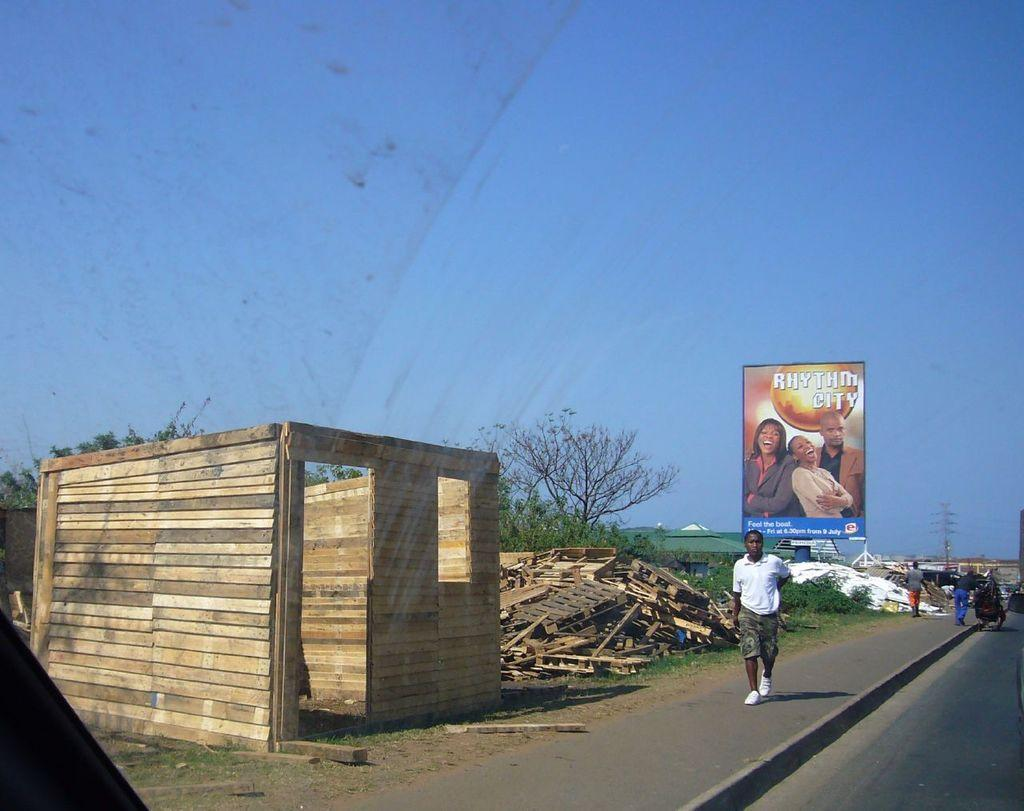<image>
Offer a succinct explanation of the picture presented. A sign for Rythm City can be seen with a person walking in front of it. 